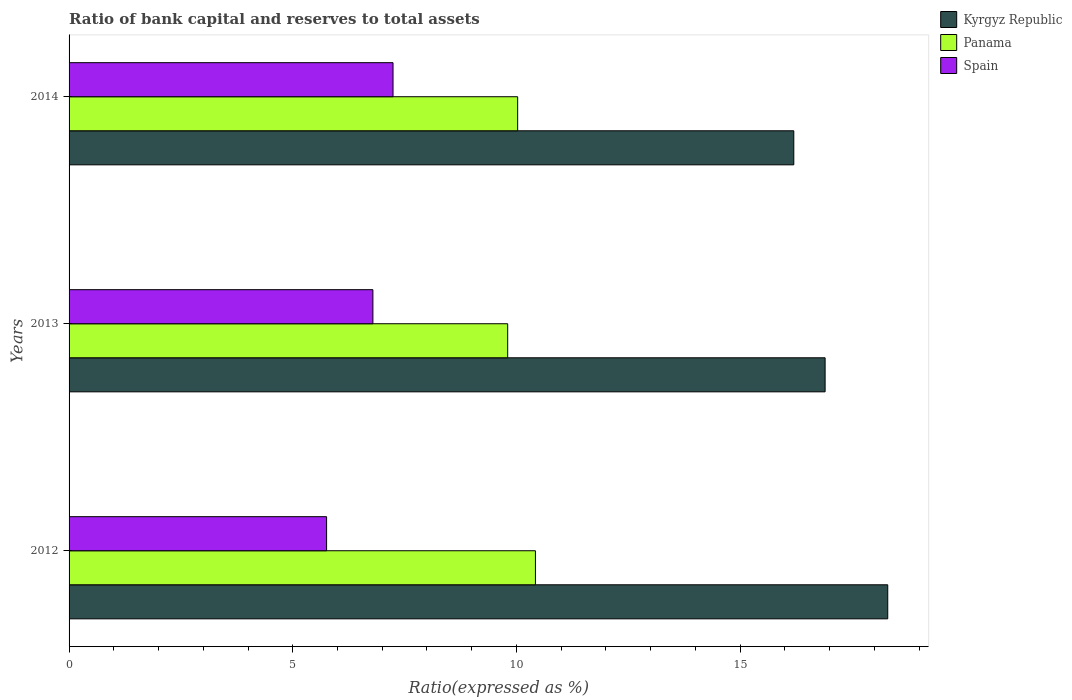How many different coloured bars are there?
Offer a very short reply. 3. Are the number of bars per tick equal to the number of legend labels?
Give a very brief answer. Yes. Are the number of bars on each tick of the Y-axis equal?
Make the answer very short. Yes. How many bars are there on the 2nd tick from the top?
Make the answer very short. 3. How many bars are there on the 1st tick from the bottom?
Provide a succinct answer. 3. Across all years, what is the maximum ratio of bank capital and reserves to total assets in Spain?
Your answer should be compact. 7.24. Across all years, what is the minimum ratio of bank capital and reserves to total assets in Spain?
Make the answer very short. 5.76. In which year was the ratio of bank capital and reserves to total assets in Panama maximum?
Offer a very short reply. 2012. What is the total ratio of bank capital and reserves to total assets in Spain in the graph?
Offer a very short reply. 19.79. What is the difference between the ratio of bank capital and reserves to total assets in Kyrgyz Republic in 2013 and that in 2014?
Your response must be concise. 0.7. What is the difference between the ratio of bank capital and reserves to total assets in Kyrgyz Republic in 2014 and the ratio of bank capital and reserves to total assets in Panama in 2012?
Provide a short and direct response. 5.78. What is the average ratio of bank capital and reserves to total assets in Panama per year?
Offer a very short reply. 10.09. In the year 2012, what is the difference between the ratio of bank capital and reserves to total assets in Panama and ratio of bank capital and reserves to total assets in Spain?
Ensure brevity in your answer.  4.67. What is the ratio of the ratio of bank capital and reserves to total assets in Spain in 2012 to that in 2013?
Your response must be concise. 0.85. What is the difference between the highest and the second highest ratio of bank capital and reserves to total assets in Panama?
Your response must be concise. 0.4. What is the difference between the highest and the lowest ratio of bank capital and reserves to total assets in Spain?
Your answer should be very brief. 1.49. In how many years, is the ratio of bank capital and reserves to total assets in Panama greater than the average ratio of bank capital and reserves to total assets in Panama taken over all years?
Offer a very short reply. 1. Is the sum of the ratio of bank capital and reserves to total assets in Panama in 2012 and 2014 greater than the maximum ratio of bank capital and reserves to total assets in Spain across all years?
Provide a short and direct response. Yes. What does the 2nd bar from the top in 2014 represents?
Make the answer very short. Panama. What does the 1st bar from the bottom in 2013 represents?
Ensure brevity in your answer.  Kyrgyz Republic. How many bars are there?
Provide a succinct answer. 9. Are all the bars in the graph horizontal?
Provide a short and direct response. Yes. Where does the legend appear in the graph?
Provide a succinct answer. Top right. How many legend labels are there?
Make the answer very short. 3. What is the title of the graph?
Offer a very short reply. Ratio of bank capital and reserves to total assets. Does "Mauritania" appear as one of the legend labels in the graph?
Make the answer very short. No. What is the label or title of the X-axis?
Keep it short and to the point. Ratio(expressed as %). What is the Ratio(expressed as %) in Kyrgyz Republic in 2012?
Give a very brief answer. 18.3. What is the Ratio(expressed as %) of Panama in 2012?
Your response must be concise. 10.42. What is the Ratio(expressed as %) in Spain in 2012?
Provide a succinct answer. 5.76. What is the Ratio(expressed as %) of Panama in 2013?
Offer a terse response. 9.8. What is the Ratio(expressed as %) of Spain in 2013?
Offer a very short reply. 6.79. What is the Ratio(expressed as %) of Panama in 2014?
Provide a short and direct response. 10.03. What is the Ratio(expressed as %) in Spain in 2014?
Offer a very short reply. 7.24. Across all years, what is the maximum Ratio(expressed as %) of Panama?
Your response must be concise. 10.42. Across all years, what is the maximum Ratio(expressed as %) of Spain?
Offer a very short reply. 7.24. Across all years, what is the minimum Ratio(expressed as %) of Panama?
Your answer should be very brief. 9.8. Across all years, what is the minimum Ratio(expressed as %) of Spain?
Give a very brief answer. 5.76. What is the total Ratio(expressed as %) of Kyrgyz Republic in the graph?
Make the answer very short. 51.4. What is the total Ratio(expressed as %) in Panama in the graph?
Offer a terse response. 30.26. What is the total Ratio(expressed as %) in Spain in the graph?
Provide a short and direct response. 19.79. What is the difference between the Ratio(expressed as %) in Kyrgyz Republic in 2012 and that in 2013?
Give a very brief answer. 1.4. What is the difference between the Ratio(expressed as %) of Panama in 2012 and that in 2013?
Make the answer very short. 0.62. What is the difference between the Ratio(expressed as %) in Spain in 2012 and that in 2013?
Your answer should be very brief. -1.04. What is the difference between the Ratio(expressed as %) in Kyrgyz Republic in 2012 and that in 2014?
Your response must be concise. 2.1. What is the difference between the Ratio(expressed as %) in Panama in 2012 and that in 2014?
Keep it short and to the point. 0.4. What is the difference between the Ratio(expressed as %) in Spain in 2012 and that in 2014?
Give a very brief answer. -1.49. What is the difference between the Ratio(expressed as %) in Kyrgyz Republic in 2013 and that in 2014?
Provide a succinct answer. 0.7. What is the difference between the Ratio(expressed as %) in Panama in 2013 and that in 2014?
Offer a terse response. -0.22. What is the difference between the Ratio(expressed as %) of Spain in 2013 and that in 2014?
Your response must be concise. -0.45. What is the difference between the Ratio(expressed as %) of Kyrgyz Republic in 2012 and the Ratio(expressed as %) of Panama in 2013?
Offer a terse response. 8.5. What is the difference between the Ratio(expressed as %) of Kyrgyz Republic in 2012 and the Ratio(expressed as %) of Spain in 2013?
Give a very brief answer. 11.51. What is the difference between the Ratio(expressed as %) in Panama in 2012 and the Ratio(expressed as %) in Spain in 2013?
Offer a terse response. 3.63. What is the difference between the Ratio(expressed as %) of Kyrgyz Republic in 2012 and the Ratio(expressed as %) of Panama in 2014?
Offer a very short reply. 8.27. What is the difference between the Ratio(expressed as %) in Kyrgyz Republic in 2012 and the Ratio(expressed as %) in Spain in 2014?
Provide a short and direct response. 11.06. What is the difference between the Ratio(expressed as %) in Panama in 2012 and the Ratio(expressed as %) in Spain in 2014?
Your answer should be very brief. 3.18. What is the difference between the Ratio(expressed as %) in Kyrgyz Republic in 2013 and the Ratio(expressed as %) in Panama in 2014?
Give a very brief answer. 6.87. What is the difference between the Ratio(expressed as %) of Kyrgyz Republic in 2013 and the Ratio(expressed as %) of Spain in 2014?
Provide a short and direct response. 9.66. What is the difference between the Ratio(expressed as %) of Panama in 2013 and the Ratio(expressed as %) of Spain in 2014?
Provide a succinct answer. 2.56. What is the average Ratio(expressed as %) in Kyrgyz Republic per year?
Make the answer very short. 17.13. What is the average Ratio(expressed as %) in Panama per year?
Your response must be concise. 10.09. What is the average Ratio(expressed as %) of Spain per year?
Keep it short and to the point. 6.6. In the year 2012, what is the difference between the Ratio(expressed as %) in Kyrgyz Republic and Ratio(expressed as %) in Panama?
Offer a terse response. 7.88. In the year 2012, what is the difference between the Ratio(expressed as %) of Kyrgyz Republic and Ratio(expressed as %) of Spain?
Provide a succinct answer. 12.54. In the year 2012, what is the difference between the Ratio(expressed as %) in Panama and Ratio(expressed as %) in Spain?
Ensure brevity in your answer.  4.67. In the year 2013, what is the difference between the Ratio(expressed as %) in Kyrgyz Republic and Ratio(expressed as %) in Panama?
Your answer should be very brief. 7.1. In the year 2013, what is the difference between the Ratio(expressed as %) of Kyrgyz Republic and Ratio(expressed as %) of Spain?
Your answer should be very brief. 10.11. In the year 2013, what is the difference between the Ratio(expressed as %) of Panama and Ratio(expressed as %) of Spain?
Provide a succinct answer. 3.01. In the year 2014, what is the difference between the Ratio(expressed as %) of Kyrgyz Republic and Ratio(expressed as %) of Panama?
Give a very brief answer. 6.17. In the year 2014, what is the difference between the Ratio(expressed as %) of Kyrgyz Republic and Ratio(expressed as %) of Spain?
Your answer should be very brief. 8.96. In the year 2014, what is the difference between the Ratio(expressed as %) of Panama and Ratio(expressed as %) of Spain?
Give a very brief answer. 2.79. What is the ratio of the Ratio(expressed as %) of Kyrgyz Republic in 2012 to that in 2013?
Offer a very short reply. 1.08. What is the ratio of the Ratio(expressed as %) in Panama in 2012 to that in 2013?
Keep it short and to the point. 1.06. What is the ratio of the Ratio(expressed as %) of Spain in 2012 to that in 2013?
Your answer should be compact. 0.85. What is the ratio of the Ratio(expressed as %) in Kyrgyz Republic in 2012 to that in 2014?
Your answer should be compact. 1.13. What is the ratio of the Ratio(expressed as %) in Panama in 2012 to that in 2014?
Keep it short and to the point. 1.04. What is the ratio of the Ratio(expressed as %) of Spain in 2012 to that in 2014?
Your answer should be compact. 0.79. What is the ratio of the Ratio(expressed as %) in Kyrgyz Republic in 2013 to that in 2014?
Provide a short and direct response. 1.04. What is the ratio of the Ratio(expressed as %) in Panama in 2013 to that in 2014?
Provide a short and direct response. 0.98. What is the ratio of the Ratio(expressed as %) in Spain in 2013 to that in 2014?
Your answer should be very brief. 0.94. What is the difference between the highest and the second highest Ratio(expressed as %) in Kyrgyz Republic?
Your answer should be very brief. 1.4. What is the difference between the highest and the second highest Ratio(expressed as %) in Panama?
Ensure brevity in your answer.  0.4. What is the difference between the highest and the second highest Ratio(expressed as %) in Spain?
Give a very brief answer. 0.45. What is the difference between the highest and the lowest Ratio(expressed as %) in Kyrgyz Republic?
Provide a succinct answer. 2.1. What is the difference between the highest and the lowest Ratio(expressed as %) in Panama?
Give a very brief answer. 0.62. What is the difference between the highest and the lowest Ratio(expressed as %) of Spain?
Ensure brevity in your answer.  1.49. 